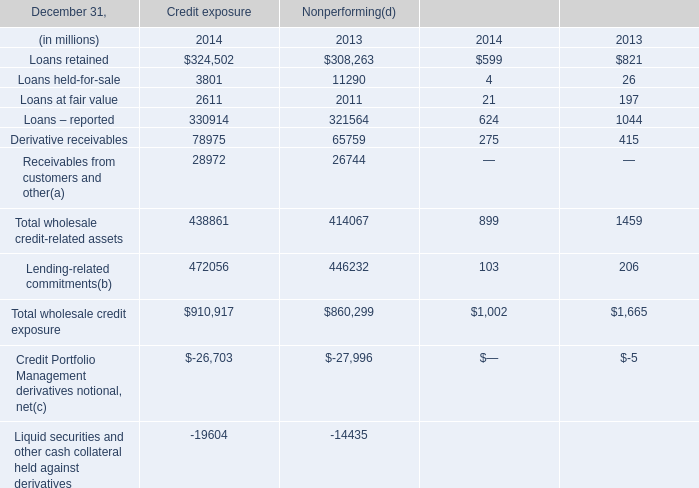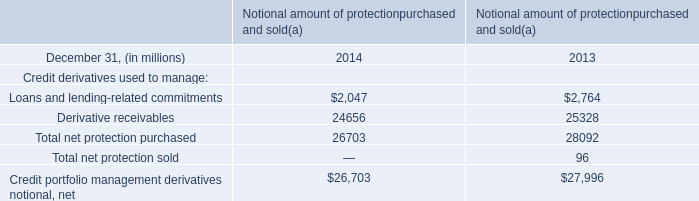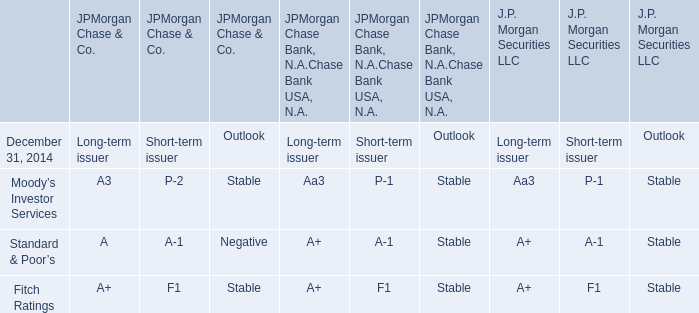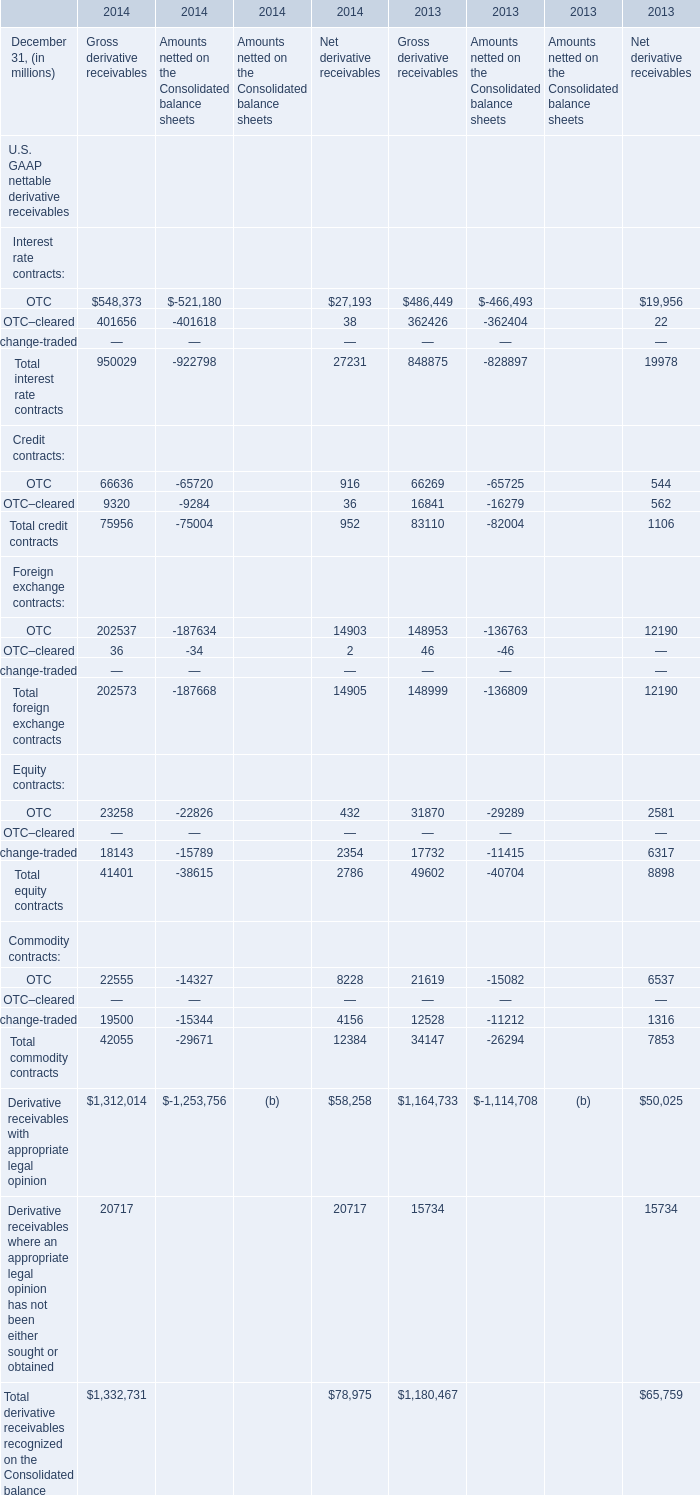What is the sum of OTC for Gross derivative receivables in 2014 and Loans and lending-related commitments in 2014 ? 
Computations: (2047 + 548373)
Answer: 550420.0. 